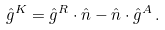<formula> <loc_0><loc_0><loc_500><loc_500>\hat { g } ^ { K } = \hat { g } ^ { R } \cdot \hat { n } - \hat { n } \cdot \hat { g } ^ { A } \, .</formula> 